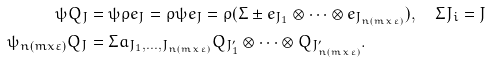Convert formula to latex. <formula><loc_0><loc_0><loc_500><loc_500>\psi Q _ { J } & = \psi \rho e _ { J } = \rho \psi e _ { J } = \rho ( \Sigma \pm e _ { J _ { 1 } } \otimes \cdots \otimes e _ { J _ { n ( m x \varepsilon ) } } ) , \quad \Sigma J _ { i } = J \\ \psi _ { n ( m x \varepsilon ) } Q _ { J } & = \Sigma a _ { J _ { 1 } , \dots , J _ { n ( m x \varepsilon ) } } Q _ { J _ { 1 } ^ { \prime } } \otimes \cdots \otimes Q _ { J _ { n ( m x \varepsilon ) } ^ { \prime } } .</formula> 